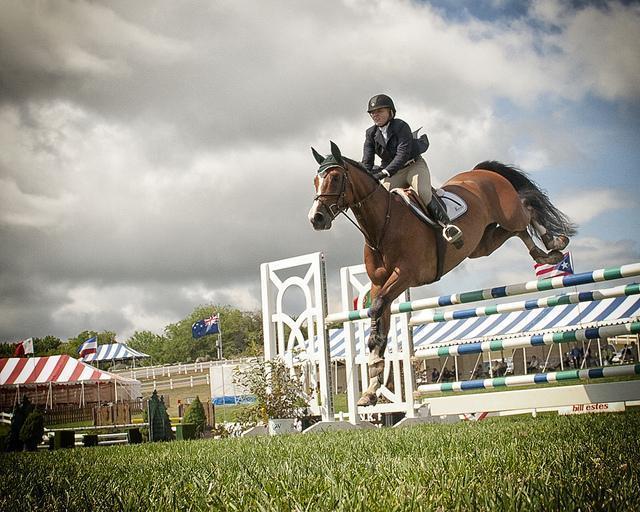How many horses are in the photo?
Give a very brief answer. 1. How many people are on the boat not at the dock?
Give a very brief answer. 0. 